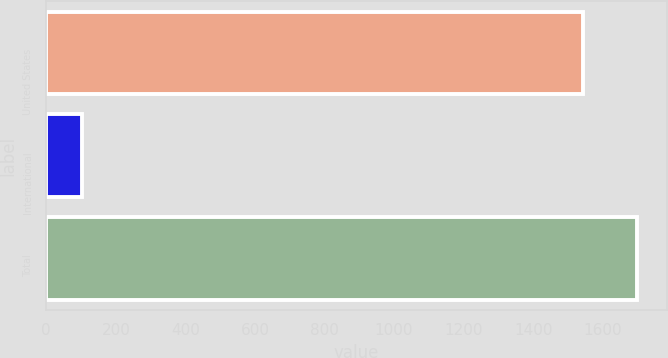<chart> <loc_0><loc_0><loc_500><loc_500><bar_chart><fcel>United States<fcel>International<fcel>Total<nl><fcel>1544.2<fcel>102.8<fcel>1698.62<nl></chart> 